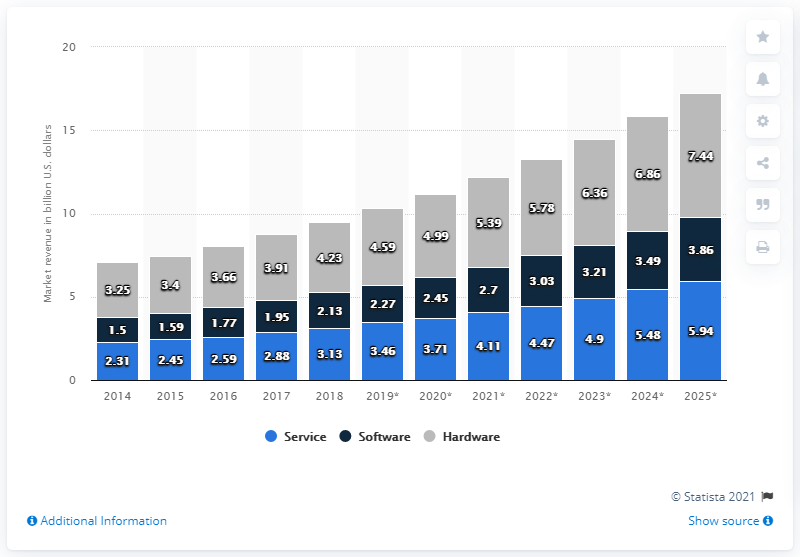Specify some key components in this picture. The projected value of the U.S. interactive kiosk market by 2025 is expected to be approximately 7.44. In 2018, the hardware component of the U.S. interactive kiosk market was valued at approximately $4.23 billion. 